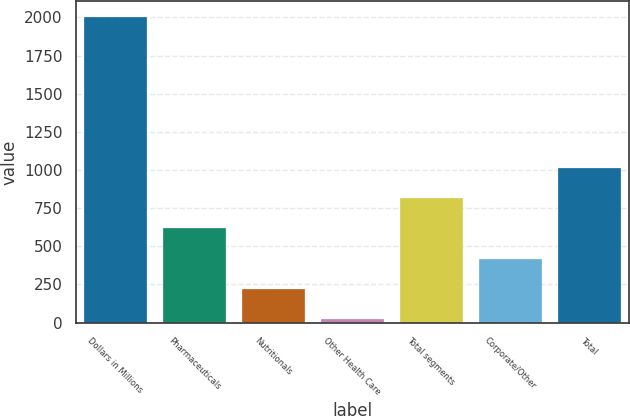Convert chart to OTSL. <chart><loc_0><loc_0><loc_500><loc_500><bar_chart><fcel>Dollars in Millions<fcel>Pharmaceuticals<fcel>Nutritionals<fcel>Other Health Care<fcel>Total segments<fcel>Corporate/Other<fcel>Total<nl><fcel>2004<fcel>616.6<fcel>220.2<fcel>22<fcel>814.8<fcel>418.4<fcel>1013<nl></chart> 